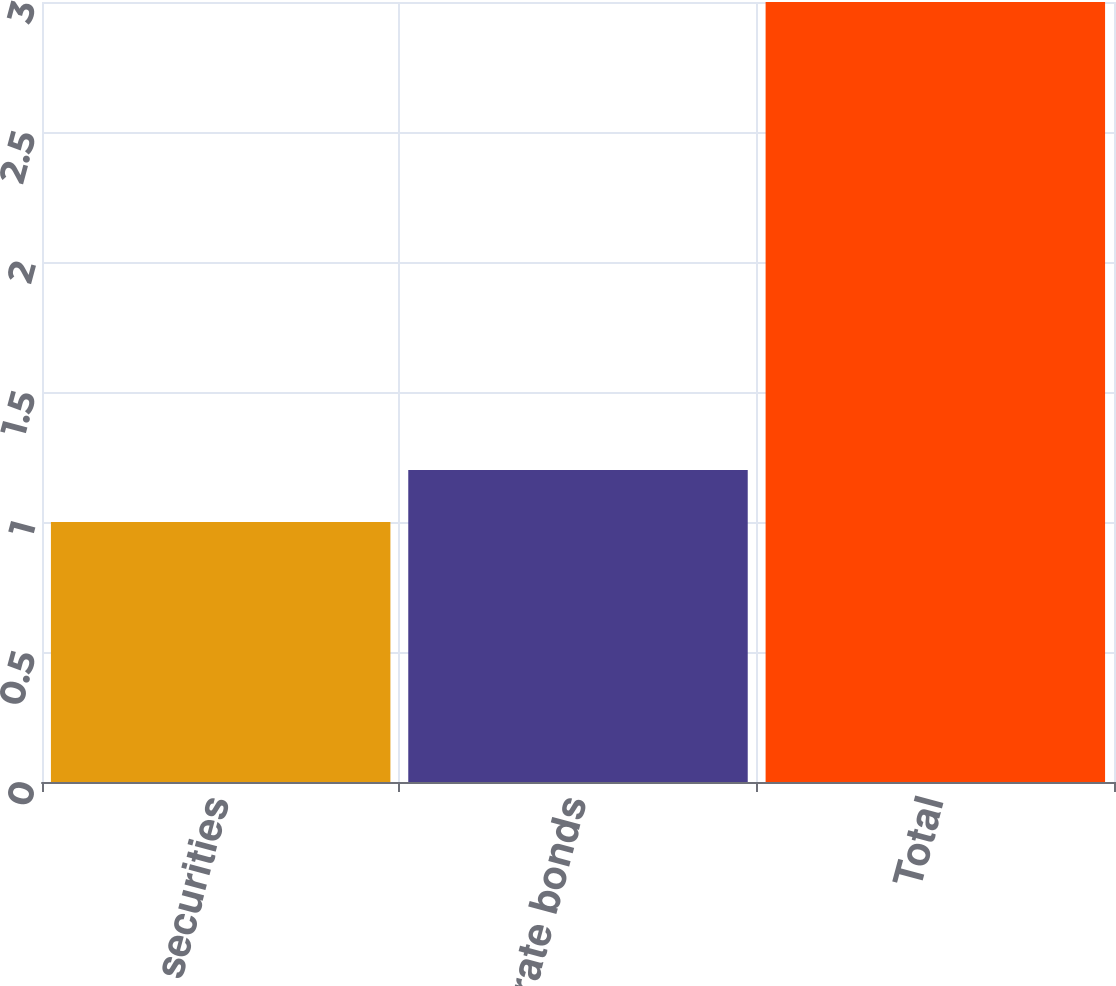Convert chart to OTSL. <chart><loc_0><loc_0><loc_500><loc_500><bar_chart><fcel>US agency securities<fcel>Corporate bonds<fcel>Total<nl><fcel>1<fcel>1.2<fcel>3<nl></chart> 